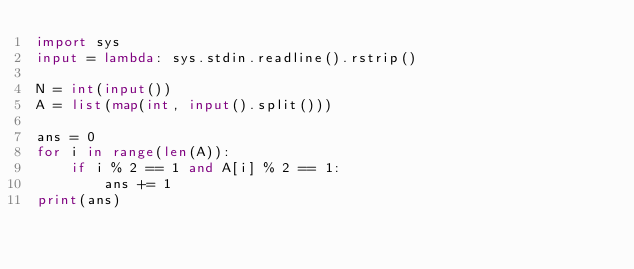<code> <loc_0><loc_0><loc_500><loc_500><_Python_>import sys
input = lambda: sys.stdin.readline().rstrip()

N = int(input())
A = list(map(int, input().split()))

ans = 0
for i in range(len(A)):
    if i % 2 == 1 and A[i] % 2 == 1:
        ans += 1
print(ans)        </code> 